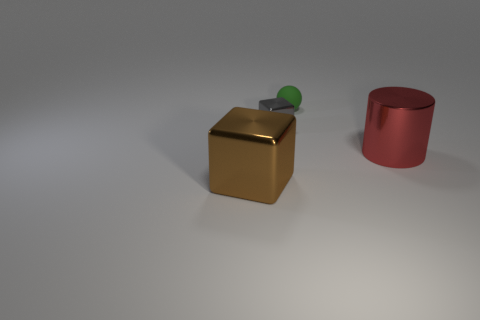What material is the big thing that is on the right side of the small gray block?
Keep it short and to the point. Metal. What number of shiny objects are balls or large purple balls?
Provide a short and direct response. 0. Are there any other shiny things of the same size as the green object?
Provide a short and direct response. Yes. Is the number of blocks that are in front of the shiny cylinder greater than the number of small purple metallic spheres?
Provide a succinct answer. Yes. What number of large things are rubber spheres or gray metallic cubes?
Ensure brevity in your answer.  0. How many other shiny objects are the same shape as the gray metal thing?
Offer a terse response. 1. There is a cube left of the metal block that is on the right side of the brown block; what is it made of?
Your answer should be very brief. Metal. What is the size of the cube that is in front of the big red cylinder?
Offer a terse response. Large. How many red things are either large metallic spheres or large metal cylinders?
Ensure brevity in your answer.  1. Is there any other thing that is the same material as the tiny green object?
Provide a succinct answer. No. 